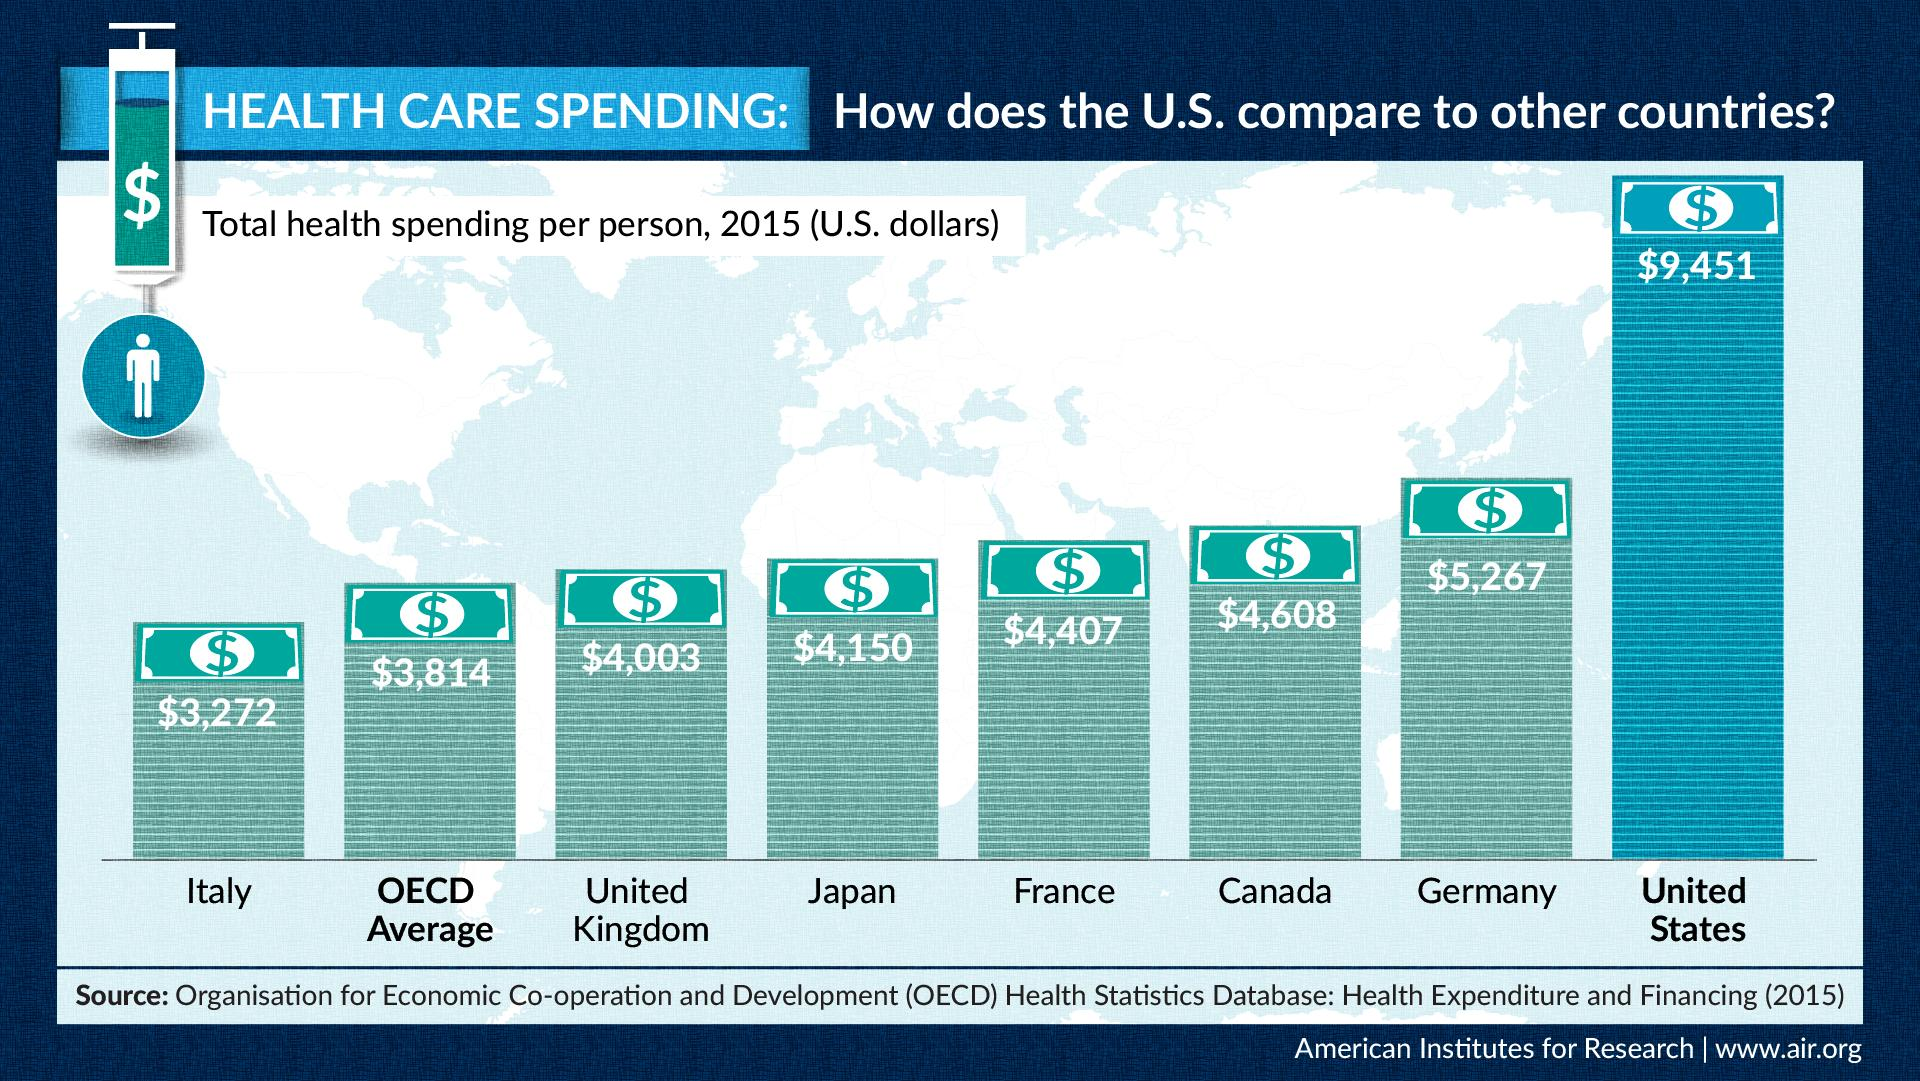Give some essential details in this illustration. In the year 2015, Italy had the lowest total health spending per person when compared to the United States. In the year 2015, the total health spending per person in the United States was $9,451. In 2015, the total health spending per person in Japan was $4,150. According to data from the year 2015, Germany has the highest total health spending per person, surpassing the United States. 